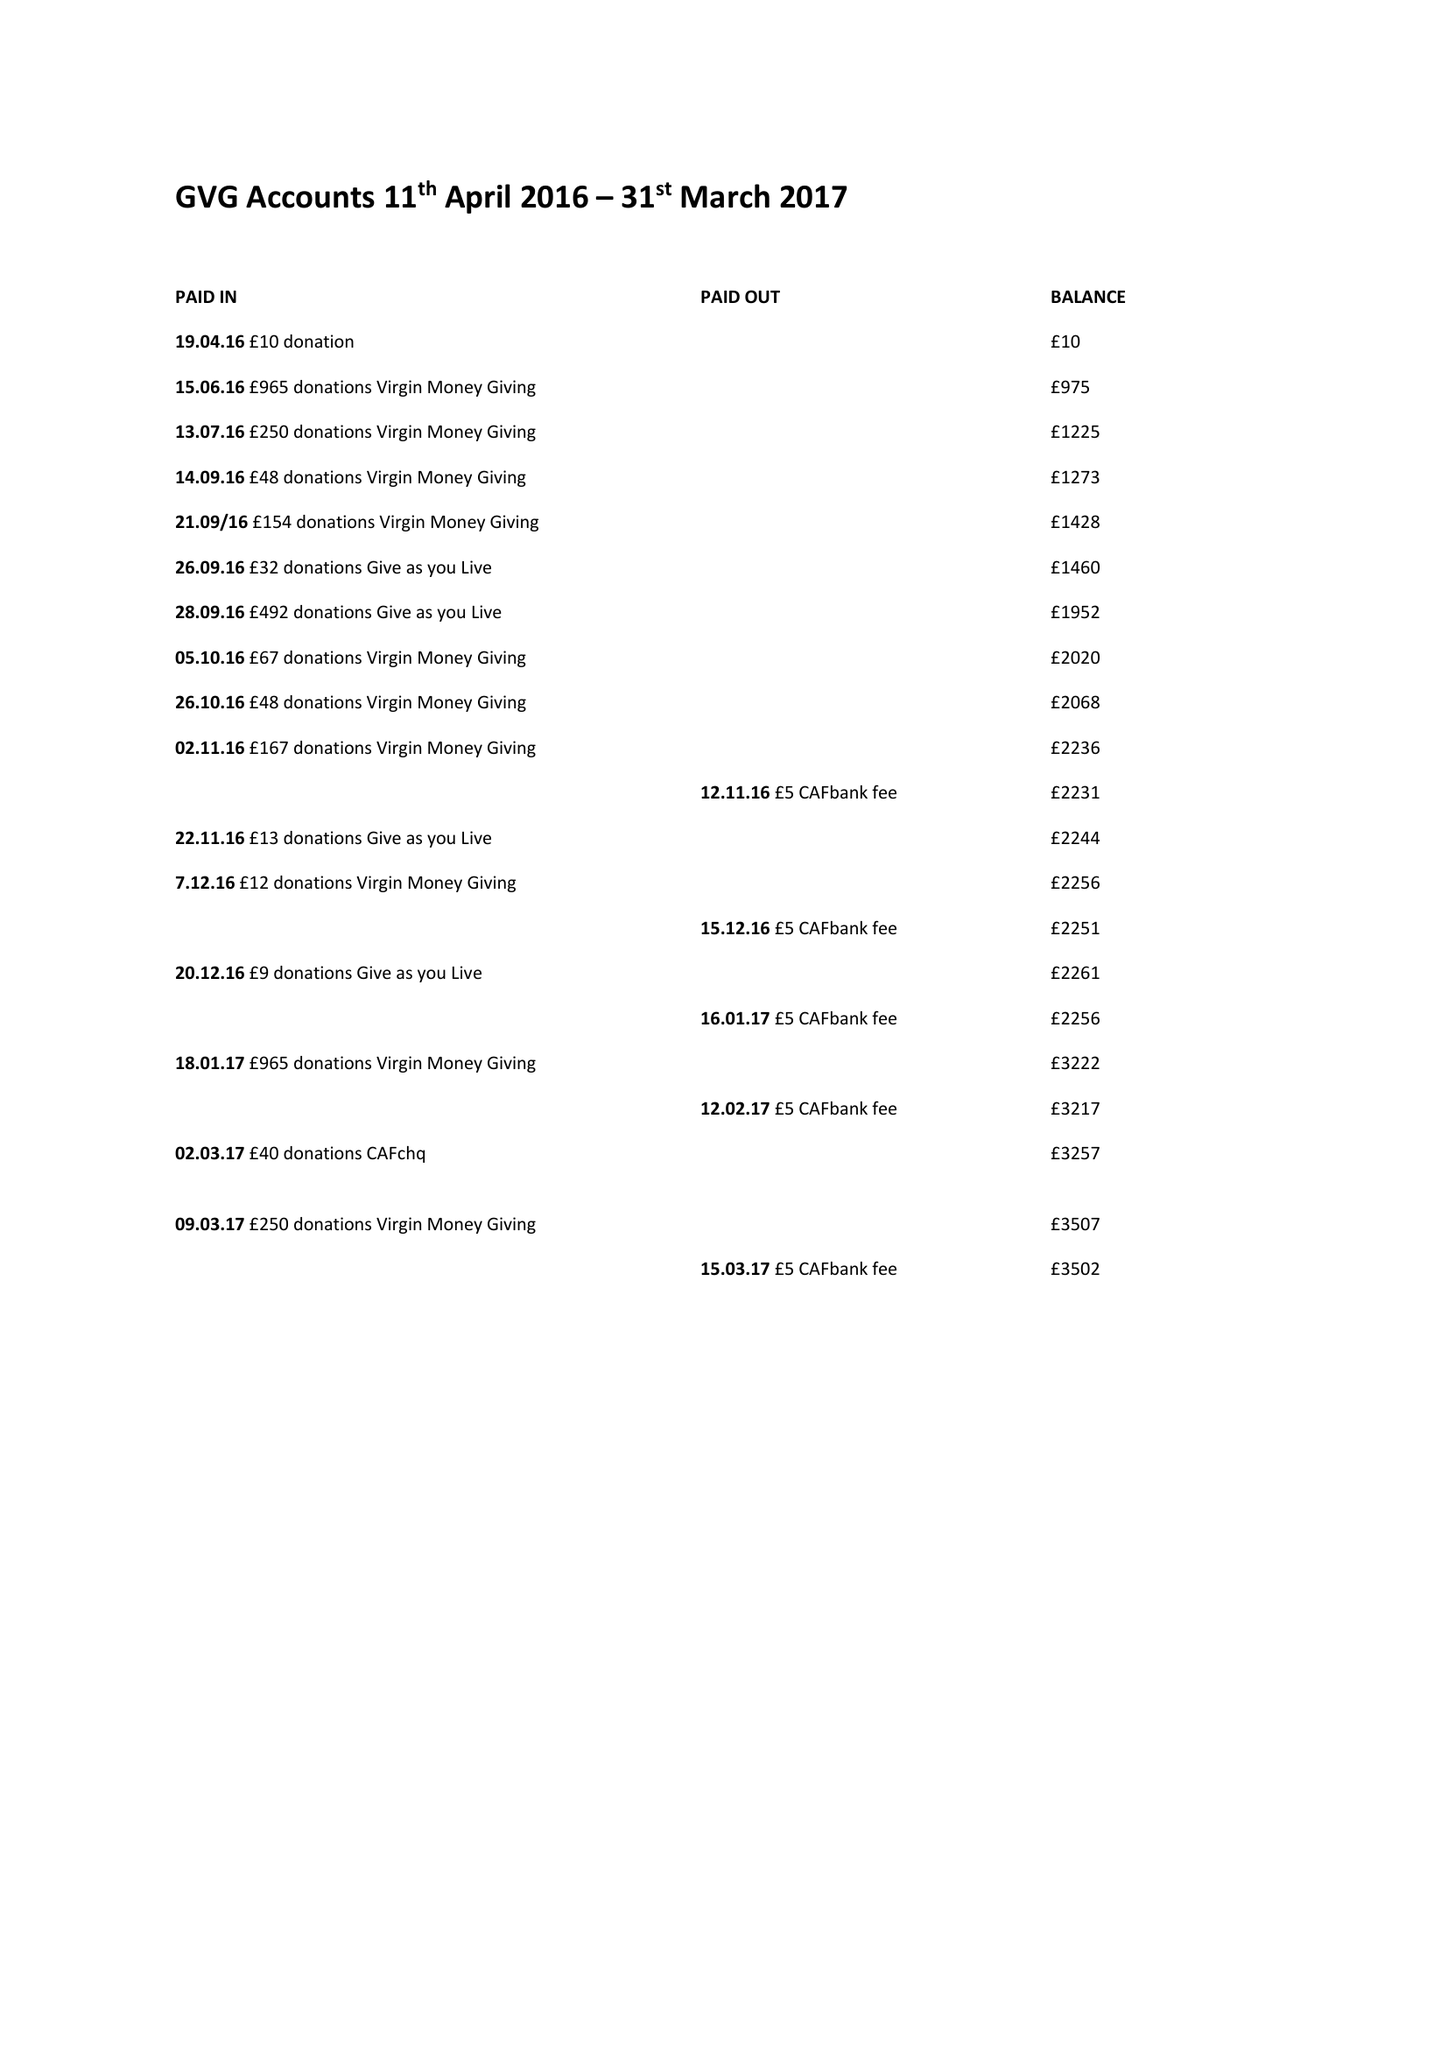What is the value for the address__postcode?
Answer the question using a single word or phrase. SW18 3AU 